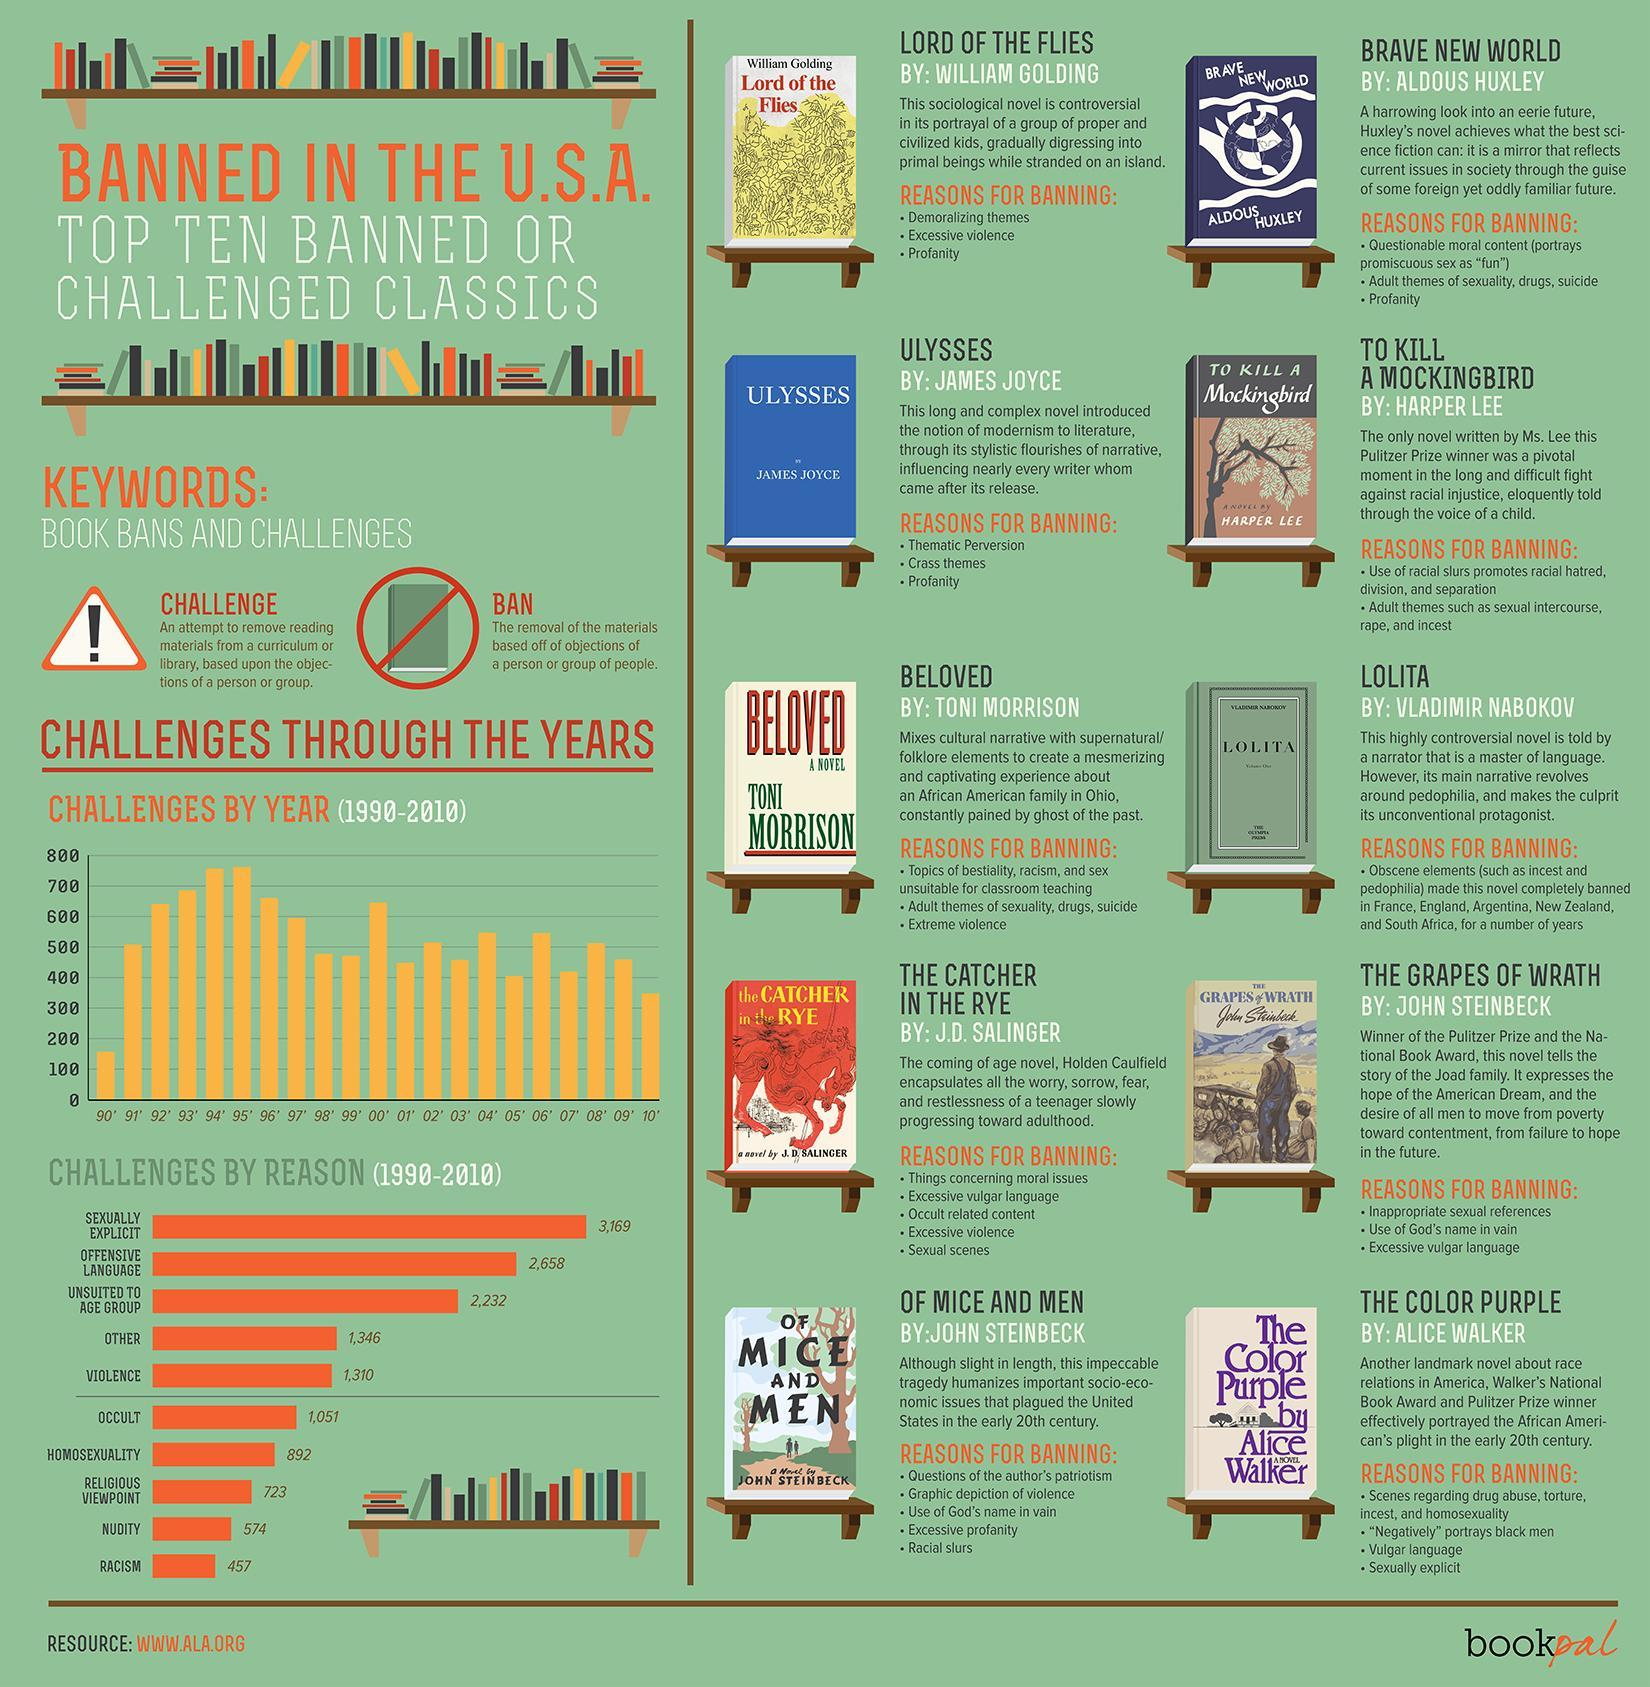how many books were challenged in 2010?
Answer the question with a short phrase. 350 How many books were challenged because of sexual explicit or offensive language? 5827 How many years are there in bar chart with 500 or more challenges? 12 what is the second most considerable reason for challenge? offensive language what is the top reason for challenge? sexuality explicit 